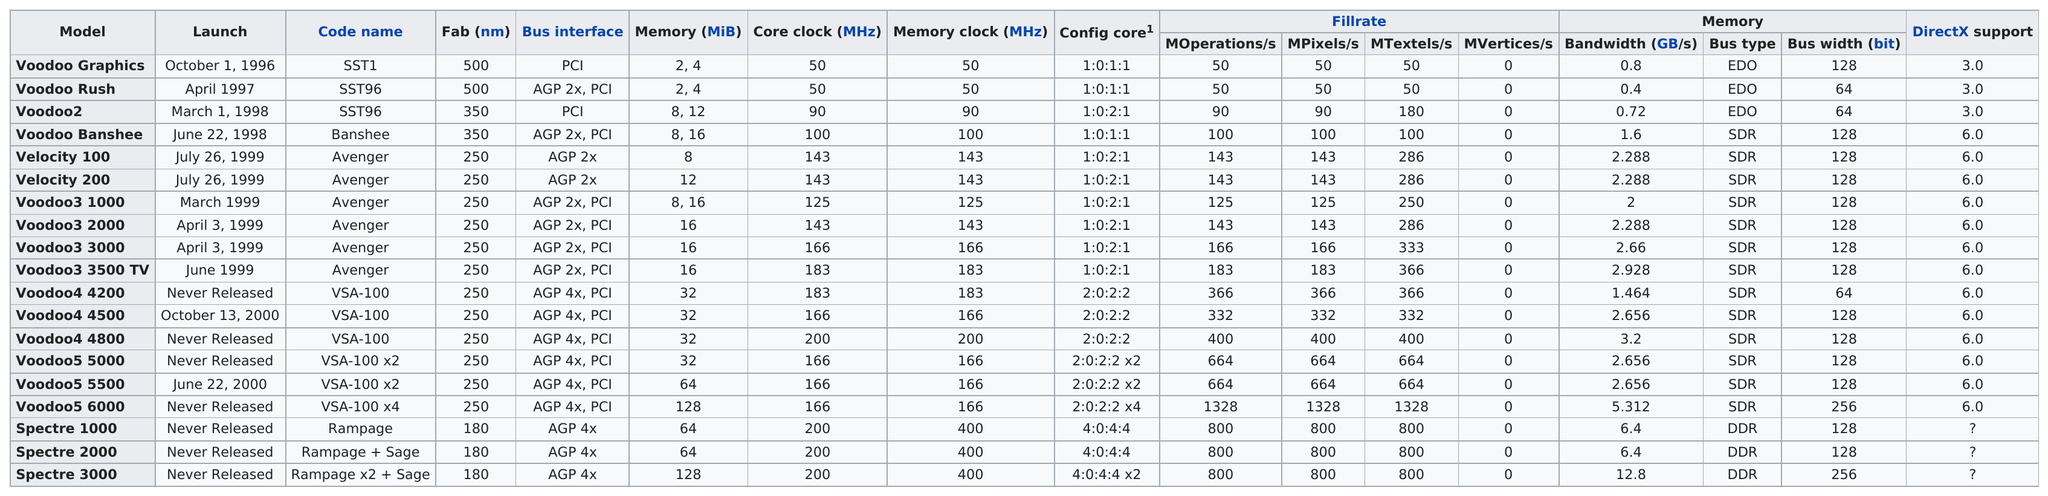Mention a couple of crucial points in this snapshot. The Voodoo3 3500 TV is the model that comes after the Voodoo3 3000. In 1999, 6 models were launched. It is widely known that the Voodoo5 6000 model of graphics card has the largest bandwidth among all similar models in the market. This makes it a highly sought-after choice for gamers and tech enthusiasts who require high-performance graphics processing. April 1997 comes before March 1, 1998 in terms of launch date. The next code name after SST1 is SST96. 